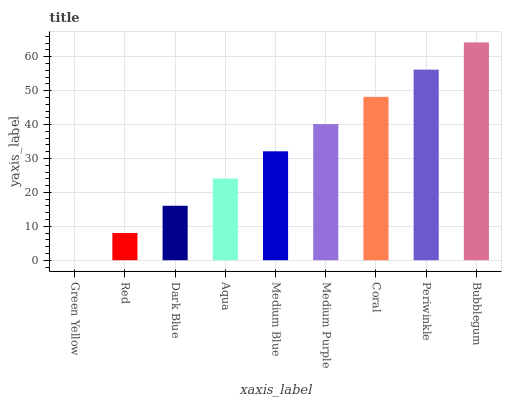Is Green Yellow the minimum?
Answer yes or no. Yes. Is Bubblegum the maximum?
Answer yes or no. Yes. Is Red the minimum?
Answer yes or no. No. Is Red the maximum?
Answer yes or no. No. Is Red greater than Green Yellow?
Answer yes or no. Yes. Is Green Yellow less than Red?
Answer yes or no. Yes. Is Green Yellow greater than Red?
Answer yes or no. No. Is Red less than Green Yellow?
Answer yes or no. No. Is Medium Blue the high median?
Answer yes or no. Yes. Is Medium Blue the low median?
Answer yes or no. Yes. Is Red the high median?
Answer yes or no. No. Is Periwinkle the low median?
Answer yes or no. No. 